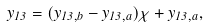<formula> <loc_0><loc_0><loc_500><loc_500>y _ { 1 3 } = ( y _ { 1 3 , b } - y _ { 1 3 , a } ) \chi + y _ { 1 3 , a } ,</formula> 